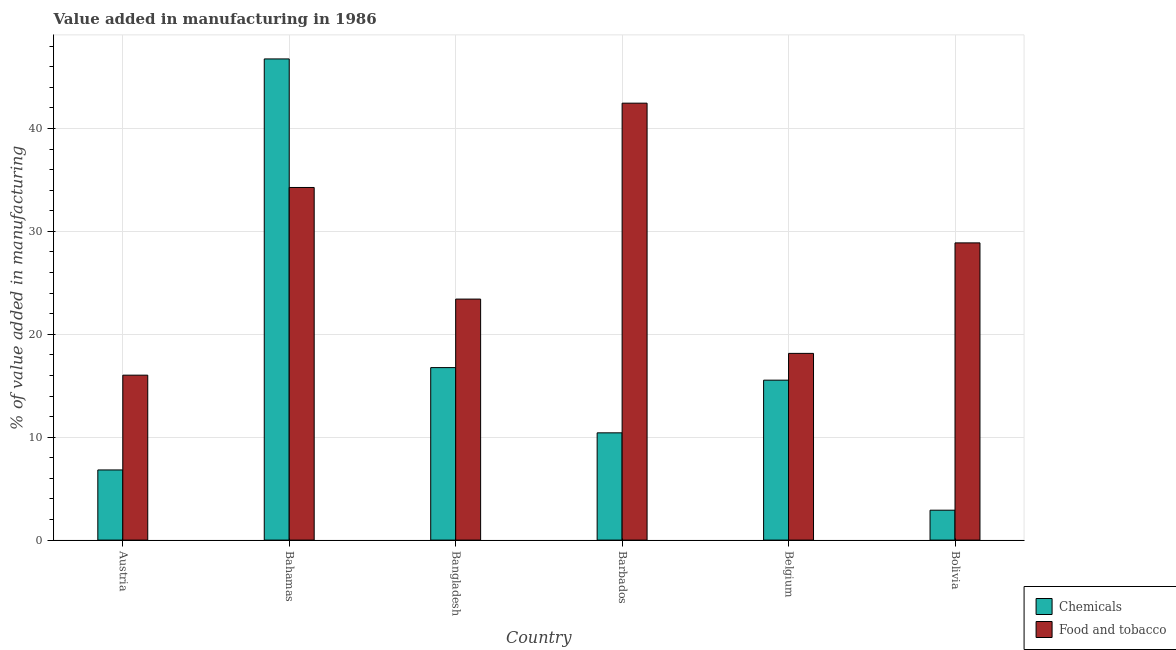How many different coloured bars are there?
Make the answer very short. 2. Are the number of bars per tick equal to the number of legend labels?
Provide a succinct answer. Yes. Are the number of bars on each tick of the X-axis equal?
Give a very brief answer. Yes. How many bars are there on the 2nd tick from the left?
Make the answer very short. 2. How many bars are there on the 2nd tick from the right?
Keep it short and to the point. 2. What is the label of the 4th group of bars from the left?
Give a very brief answer. Barbados. What is the value added by manufacturing food and tobacco in Belgium?
Provide a short and direct response. 18.14. Across all countries, what is the maximum value added by  manufacturing chemicals?
Keep it short and to the point. 46.76. Across all countries, what is the minimum value added by manufacturing food and tobacco?
Keep it short and to the point. 16.03. In which country was the value added by manufacturing food and tobacco maximum?
Keep it short and to the point. Barbados. What is the total value added by  manufacturing chemicals in the graph?
Your answer should be compact. 99.2. What is the difference between the value added by manufacturing food and tobacco in Austria and that in Barbados?
Your answer should be very brief. -26.43. What is the difference between the value added by manufacturing food and tobacco in Bolivia and the value added by  manufacturing chemicals in Bahamas?
Your response must be concise. -17.88. What is the average value added by  manufacturing chemicals per country?
Offer a terse response. 16.53. What is the difference between the value added by manufacturing food and tobacco and value added by  manufacturing chemicals in Bahamas?
Ensure brevity in your answer.  -12.49. In how many countries, is the value added by  manufacturing chemicals greater than 4 %?
Your answer should be very brief. 5. What is the ratio of the value added by  manufacturing chemicals in Austria to that in Bahamas?
Offer a terse response. 0.15. What is the difference between the highest and the second highest value added by  manufacturing chemicals?
Keep it short and to the point. 29.99. What is the difference between the highest and the lowest value added by  manufacturing chemicals?
Offer a terse response. 43.85. In how many countries, is the value added by manufacturing food and tobacco greater than the average value added by manufacturing food and tobacco taken over all countries?
Your answer should be compact. 3. Is the sum of the value added by manufacturing food and tobacco in Austria and Bolivia greater than the maximum value added by  manufacturing chemicals across all countries?
Provide a succinct answer. No. What does the 1st bar from the left in Bangladesh represents?
Your answer should be compact. Chemicals. What does the 2nd bar from the right in Barbados represents?
Ensure brevity in your answer.  Chemicals. How many bars are there?
Make the answer very short. 12. What is the difference between two consecutive major ticks on the Y-axis?
Provide a succinct answer. 10. Are the values on the major ticks of Y-axis written in scientific E-notation?
Your answer should be very brief. No. How many legend labels are there?
Keep it short and to the point. 2. What is the title of the graph?
Offer a very short reply. Value added in manufacturing in 1986. Does "Rural" appear as one of the legend labels in the graph?
Provide a succinct answer. No. What is the label or title of the Y-axis?
Your response must be concise. % of value added in manufacturing. What is the % of value added in manufacturing of Chemicals in Austria?
Your answer should be very brief. 6.82. What is the % of value added in manufacturing of Food and tobacco in Austria?
Give a very brief answer. 16.03. What is the % of value added in manufacturing in Chemicals in Bahamas?
Provide a short and direct response. 46.76. What is the % of value added in manufacturing in Food and tobacco in Bahamas?
Provide a short and direct response. 34.27. What is the % of value added in manufacturing in Chemicals in Bangladesh?
Your answer should be compact. 16.76. What is the % of value added in manufacturing of Food and tobacco in Bangladesh?
Make the answer very short. 23.42. What is the % of value added in manufacturing in Chemicals in Barbados?
Your response must be concise. 10.42. What is the % of value added in manufacturing of Food and tobacco in Barbados?
Your answer should be compact. 42.46. What is the % of value added in manufacturing of Chemicals in Belgium?
Provide a succinct answer. 15.54. What is the % of value added in manufacturing in Food and tobacco in Belgium?
Provide a succinct answer. 18.14. What is the % of value added in manufacturing of Chemicals in Bolivia?
Offer a terse response. 2.91. What is the % of value added in manufacturing of Food and tobacco in Bolivia?
Keep it short and to the point. 28.88. Across all countries, what is the maximum % of value added in manufacturing in Chemicals?
Provide a short and direct response. 46.76. Across all countries, what is the maximum % of value added in manufacturing of Food and tobacco?
Your response must be concise. 42.46. Across all countries, what is the minimum % of value added in manufacturing in Chemicals?
Provide a succinct answer. 2.91. Across all countries, what is the minimum % of value added in manufacturing in Food and tobacco?
Keep it short and to the point. 16.03. What is the total % of value added in manufacturing of Chemicals in the graph?
Your answer should be compact. 99.2. What is the total % of value added in manufacturing of Food and tobacco in the graph?
Keep it short and to the point. 163.2. What is the difference between the % of value added in manufacturing of Chemicals in Austria and that in Bahamas?
Make the answer very short. -39.94. What is the difference between the % of value added in manufacturing of Food and tobacco in Austria and that in Bahamas?
Offer a terse response. -18.24. What is the difference between the % of value added in manufacturing in Chemicals in Austria and that in Bangladesh?
Offer a terse response. -9.95. What is the difference between the % of value added in manufacturing of Food and tobacco in Austria and that in Bangladesh?
Offer a terse response. -7.39. What is the difference between the % of value added in manufacturing of Chemicals in Austria and that in Barbados?
Make the answer very short. -3.61. What is the difference between the % of value added in manufacturing of Food and tobacco in Austria and that in Barbados?
Offer a terse response. -26.43. What is the difference between the % of value added in manufacturing of Chemicals in Austria and that in Belgium?
Your answer should be very brief. -8.72. What is the difference between the % of value added in manufacturing of Food and tobacco in Austria and that in Belgium?
Provide a succinct answer. -2.12. What is the difference between the % of value added in manufacturing in Chemicals in Austria and that in Bolivia?
Provide a succinct answer. 3.91. What is the difference between the % of value added in manufacturing in Food and tobacco in Austria and that in Bolivia?
Ensure brevity in your answer.  -12.85. What is the difference between the % of value added in manufacturing of Chemicals in Bahamas and that in Bangladesh?
Provide a short and direct response. 29.99. What is the difference between the % of value added in manufacturing in Food and tobacco in Bahamas and that in Bangladesh?
Offer a terse response. 10.85. What is the difference between the % of value added in manufacturing in Chemicals in Bahamas and that in Barbados?
Provide a succinct answer. 36.33. What is the difference between the % of value added in manufacturing of Food and tobacco in Bahamas and that in Barbados?
Ensure brevity in your answer.  -8.19. What is the difference between the % of value added in manufacturing of Chemicals in Bahamas and that in Belgium?
Your answer should be very brief. 31.22. What is the difference between the % of value added in manufacturing in Food and tobacco in Bahamas and that in Belgium?
Your answer should be very brief. 16.12. What is the difference between the % of value added in manufacturing of Chemicals in Bahamas and that in Bolivia?
Offer a terse response. 43.85. What is the difference between the % of value added in manufacturing of Food and tobacco in Bahamas and that in Bolivia?
Provide a short and direct response. 5.39. What is the difference between the % of value added in manufacturing in Chemicals in Bangladesh and that in Barbados?
Your response must be concise. 6.34. What is the difference between the % of value added in manufacturing in Food and tobacco in Bangladesh and that in Barbados?
Make the answer very short. -19.04. What is the difference between the % of value added in manufacturing in Chemicals in Bangladesh and that in Belgium?
Your answer should be very brief. 1.22. What is the difference between the % of value added in manufacturing in Food and tobacco in Bangladesh and that in Belgium?
Provide a short and direct response. 5.28. What is the difference between the % of value added in manufacturing in Chemicals in Bangladesh and that in Bolivia?
Offer a very short reply. 13.86. What is the difference between the % of value added in manufacturing of Food and tobacco in Bangladesh and that in Bolivia?
Make the answer very short. -5.46. What is the difference between the % of value added in manufacturing in Chemicals in Barbados and that in Belgium?
Provide a short and direct response. -5.12. What is the difference between the % of value added in manufacturing of Food and tobacco in Barbados and that in Belgium?
Give a very brief answer. 24.31. What is the difference between the % of value added in manufacturing of Chemicals in Barbados and that in Bolivia?
Make the answer very short. 7.52. What is the difference between the % of value added in manufacturing of Food and tobacco in Barbados and that in Bolivia?
Offer a very short reply. 13.58. What is the difference between the % of value added in manufacturing in Chemicals in Belgium and that in Bolivia?
Ensure brevity in your answer.  12.64. What is the difference between the % of value added in manufacturing of Food and tobacco in Belgium and that in Bolivia?
Offer a terse response. -10.74. What is the difference between the % of value added in manufacturing in Chemicals in Austria and the % of value added in manufacturing in Food and tobacco in Bahamas?
Provide a short and direct response. -27.45. What is the difference between the % of value added in manufacturing in Chemicals in Austria and the % of value added in manufacturing in Food and tobacco in Bangladesh?
Provide a succinct answer. -16.6. What is the difference between the % of value added in manufacturing of Chemicals in Austria and the % of value added in manufacturing of Food and tobacco in Barbados?
Offer a very short reply. -35.64. What is the difference between the % of value added in manufacturing in Chemicals in Austria and the % of value added in manufacturing in Food and tobacco in Belgium?
Offer a very short reply. -11.33. What is the difference between the % of value added in manufacturing in Chemicals in Austria and the % of value added in manufacturing in Food and tobacco in Bolivia?
Provide a succinct answer. -22.06. What is the difference between the % of value added in manufacturing of Chemicals in Bahamas and the % of value added in manufacturing of Food and tobacco in Bangladesh?
Offer a terse response. 23.34. What is the difference between the % of value added in manufacturing of Chemicals in Bahamas and the % of value added in manufacturing of Food and tobacco in Barbados?
Offer a very short reply. 4.3. What is the difference between the % of value added in manufacturing in Chemicals in Bahamas and the % of value added in manufacturing in Food and tobacco in Belgium?
Ensure brevity in your answer.  28.61. What is the difference between the % of value added in manufacturing of Chemicals in Bahamas and the % of value added in manufacturing of Food and tobacco in Bolivia?
Offer a very short reply. 17.88. What is the difference between the % of value added in manufacturing of Chemicals in Bangladesh and the % of value added in manufacturing of Food and tobacco in Barbados?
Ensure brevity in your answer.  -25.7. What is the difference between the % of value added in manufacturing in Chemicals in Bangladesh and the % of value added in manufacturing in Food and tobacco in Belgium?
Ensure brevity in your answer.  -1.38. What is the difference between the % of value added in manufacturing of Chemicals in Bangladesh and the % of value added in manufacturing of Food and tobacco in Bolivia?
Offer a very short reply. -12.12. What is the difference between the % of value added in manufacturing in Chemicals in Barbados and the % of value added in manufacturing in Food and tobacco in Belgium?
Provide a short and direct response. -7.72. What is the difference between the % of value added in manufacturing in Chemicals in Barbados and the % of value added in manufacturing in Food and tobacco in Bolivia?
Your answer should be compact. -18.46. What is the difference between the % of value added in manufacturing in Chemicals in Belgium and the % of value added in manufacturing in Food and tobacco in Bolivia?
Your response must be concise. -13.34. What is the average % of value added in manufacturing of Chemicals per country?
Your response must be concise. 16.53. What is the average % of value added in manufacturing in Food and tobacco per country?
Make the answer very short. 27.2. What is the difference between the % of value added in manufacturing of Chemicals and % of value added in manufacturing of Food and tobacco in Austria?
Ensure brevity in your answer.  -9.21. What is the difference between the % of value added in manufacturing in Chemicals and % of value added in manufacturing in Food and tobacco in Bahamas?
Provide a short and direct response. 12.49. What is the difference between the % of value added in manufacturing in Chemicals and % of value added in manufacturing in Food and tobacco in Bangladesh?
Make the answer very short. -6.66. What is the difference between the % of value added in manufacturing in Chemicals and % of value added in manufacturing in Food and tobacco in Barbados?
Provide a short and direct response. -32.03. What is the difference between the % of value added in manufacturing in Chemicals and % of value added in manufacturing in Food and tobacco in Belgium?
Offer a terse response. -2.6. What is the difference between the % of value added in manufacturing in Chemicals and % of value added in manufacturing in Food and tobacco in Bolivia?
Your answer should be compact. -25.98. What is the ratio of the % of value added in manufacturing of Chemicals in Austria to that in Bahamas?
Provide a succinct answer. 0.15. What is the ratio of the % of value added in manufacturing in Food and tobacco in Austria to that in Bahamas?
Your answer should be compact. 0.47. What is the ratio of the % of value added in manufacturing in Chemicals in Austria to that in Bangladesh?
Offer a terse response. 0.41. What is the ratio of the % of value added in manufacturing in Food and tobacco in Austria to that in Bangladesh?
Your answer should be very brief. 0.68. What is the ratio of the % of value added in manufacturing of Chemicals in Austria to that in Barbados?
Ensure brevity in your answer.  0.65. What is the ratio of the % of value added in manufacturing in Food and tobacco in Austria to that in Barbados?
Provide a succinct answer. 0.38. What is the ratio of the % of value added in manufacturing in Chemicals in Austria to that in Belgium?
Your answer should be very brief. 0.44. What is the ratio of the % of value added in manufacturing of Food and tobacco in Austria to that in Belgium?
Provide a succinct answer. 0.88. What is the ratio of the % of value added in manufacturing of Chemicals in Austria to that in Bolivia?
Your answer should be very brief. 2.35. What is the ratio of the % of value added in manufacturing in Food and tobacco in Austria to that in Bolivia?
Provide a short and direct response. 0.55. What is the ratio of the % of value added in manufacturing of Chemicals in Bahamas to that in Bangladesh?
Provide a short and direct response. 2.79. What is the ratio of the % of value added in manufacturing in Food and tobacco in Bahamas to that in Bangladesh?
Your response must be concise. 1.46. What is the ratio of the % of value added in manufacturing in Chemicals in Bahamas to that in Barbados?
Ensure brevity in your answer.  4.49. What is the ratio of the % of value added in manufacturing of Food and tobacco in Bahamas to that in Barbados?
Ensure brevity in your answer.  0.81. What is the ratio of the % of value added in manufacturing in Chemicals in Bahamas to that in Belgium?
Ensure brevity in your answer.  3.01. What is the ratio of the % of value added in manufacturing in Food and tobacco in Bahamas to that in Belgium?
Keep it short and to the point. 1.89. What is the ratio of the % of value added in manufacturing of Chemicals in Bahamas to that in Bolivia?
Your response must be concise. 16.09. What is the ratio of the % of value added in manufacturing in Food and tobacco in Bahamas to that in Bolivia?
Ensure brevity in your answer.  1.19. What is the ratio of the % of value added in manufacturing in Chemicals in Bangladesh to that in Barbados?
Provide a succinct answer. 1.61. What is the ratio of the % of value added in manufacturing of Food and tobacco in Bangladesh to that in Barbados?
Provide a succinct answer. 0.55. What is the ratio of the % of value added in manufacturing in Chemicals in Bangladesh to that in Belgium?
Your response must be concise. 1.08. What is the ratio of the % of value added in manufacturing of Food and tobacco in Bangladesh to that in Belgium?
Your answer should be very brief. 1.29. What is the ratio of the % of value added in manufacturing in Chemicals in Bangladesh to that in Bolivia?
Keep it short and to the point. 5.77. What is the ratio of the % of value added in manufacturing of Food and tobacco in Bangladesh to that in Bolivia?
Provide a short and direct response. 0.81. What is the ratio of the % of value added in manufacturing of Chemicals in Barbados to that in Belgium?
Give a very brief answer. 0.67. What is the ratio of the % of value added in manufacturing in Food and tobacco in Barbados to that in Belgium?
Keep it short and to the point. 2.34. What is the ratio of the % of value added in manufacturing in Chemicals in Barbados to that in Bolivia?
Your answer should be very brief. 3.59. What is the ratio of the % of value added in manufacturing of Food and tobacco in Barbados to that in Bolivia?
Your answer should be compact. 1.47. What is the ratio of the % of value added in manufacturing of Chemicals in Belgium to that in Bolivia?
Your answer should be very brief. 5.35. What is the ratio of the % of value added in manufacturing of Food and tobacco in Belgium to that in Bolivia?
Ensure brevity in your answer.  0.63. What is the difference between the highest and the second highest % of value added in manufacturing of Chemicals?
Give a very brief answer. 29.99. What is the difference between the highest and the second highest % of value added in manufacturing of Food and tobacco?
Your response must be concise. 8.19. What is the difference between the highest and the lowest % of value added in manufacturing in Chemicals?
Your response must be concise. 43.85. What is the difference between the highest and the lowest % of value added in manufacturing of Food and tobacco?
Offer a very short reply. 26.43. 